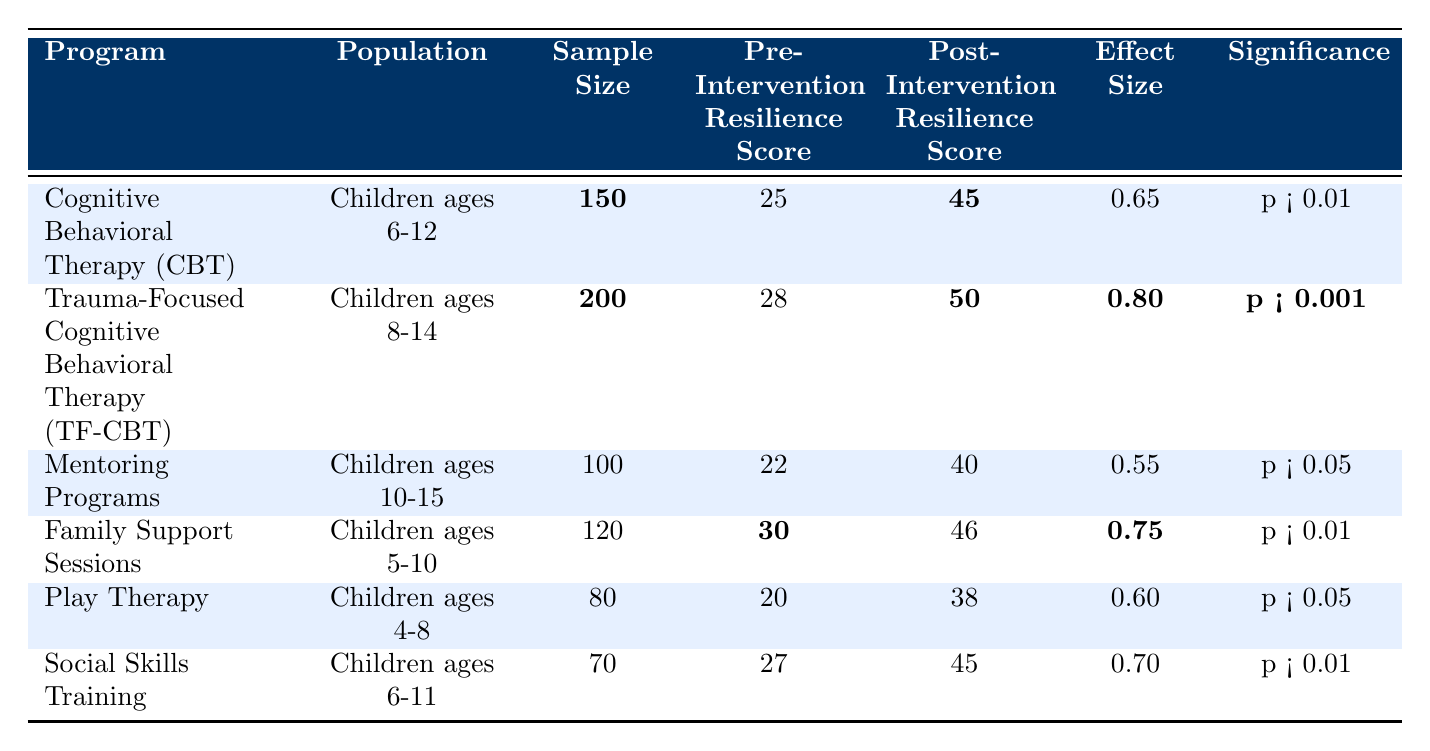What is the sample size for the Trauma-Focused Cognitive Behavioral Therapy (TF-CBT)? The sample size for TF-CBT is directly listed in the table under the "Sample Size" column. It shows **200** participants.
Answer: 200 What was the pre-intervention resilience score for the Play Therapy program? The pre-intervention resilience score for Play Therapy can be found in the table under the "Pre-Intervention Resilience Score" column. It is listed as **20**.
Answer: 20 Which intervention had the highest post-intervention resilience score? By comparing the post-intervention resilience scores in the table, we can see that Trauma-Focused Cognitive Behavioral Therapy (TF-CBT) has the highest score of **50**.
Answer: Trauma-Focused Cognitive Behavioral Therapy (TF-CBT) What is the effect size for Family Support Sessions? The effect size for Family Support Sessions is shown in the table in the "Effect Size" column. It is indicated as **0.75**.
Answer: 0.75 What is the difference between the pre- and post-intervention resilience scores for Cognitive Behavioral Therapy (CBT)? To find the difference, we subtract the pre-intervention score (25) from the post-intervention score (45), which gives us 45 - 25 = 20.
Answer: 20 Which interventions had a significance level of p < 0.01? We can identify the significance levels by reviewing the "Significance" column. The interventions with p < 0.01 are Cognitive Behavioral Therapy (CBT), Trauma-Focused Cognitive Behavioral Therapy (TF-CBT), Family Support Sessions, and Social Skills Training.
Answer: CBT, TF-CBT, Family Support Sessions, Social Skills Training What is the average post-intervention resilience score across all programs listed? First, we add all the post-intervention scores: 45 (CBT) + 50 (TF-CBT) + 40 (Mentoring Programs) + 46 (Family Support Sessions) + 38 (Play Therapy) + 45 (Social Skills Training) = 264. Then, we divide by the number of programs (6) to get the average: 264 / 6 = 44.
Answer: 44 What percent of the programs demonstrated a significant effect (p < 0.05 or better)? There are 6 programs, and 5 out of 6 have p values that indicate significant effects (CBT, TF-CBT, Family Support Sessions, Social Skills Training, and Mentoring Programs). The percentage is (5 / 6) * 100 = approximately 83.33%.
Answer: 83.33% If we consider only those programs with a sample size greater than or equal to 100, which program has the highest effect size? Reviewing only the programs with a sample size of 100 or more, we see TF-CBT (0.80) and Family Support Sessions (0.75). TF-CBT has the highest effect size of **0.80**.
Answer: 0.80 Is the resilience score improvement for Play Therapy statistically significant? Looking at the "Significance" column, Play Therapy has a significance level of p < 0.05, indicating that the improvement is statistically significant.
Answer: Yes 